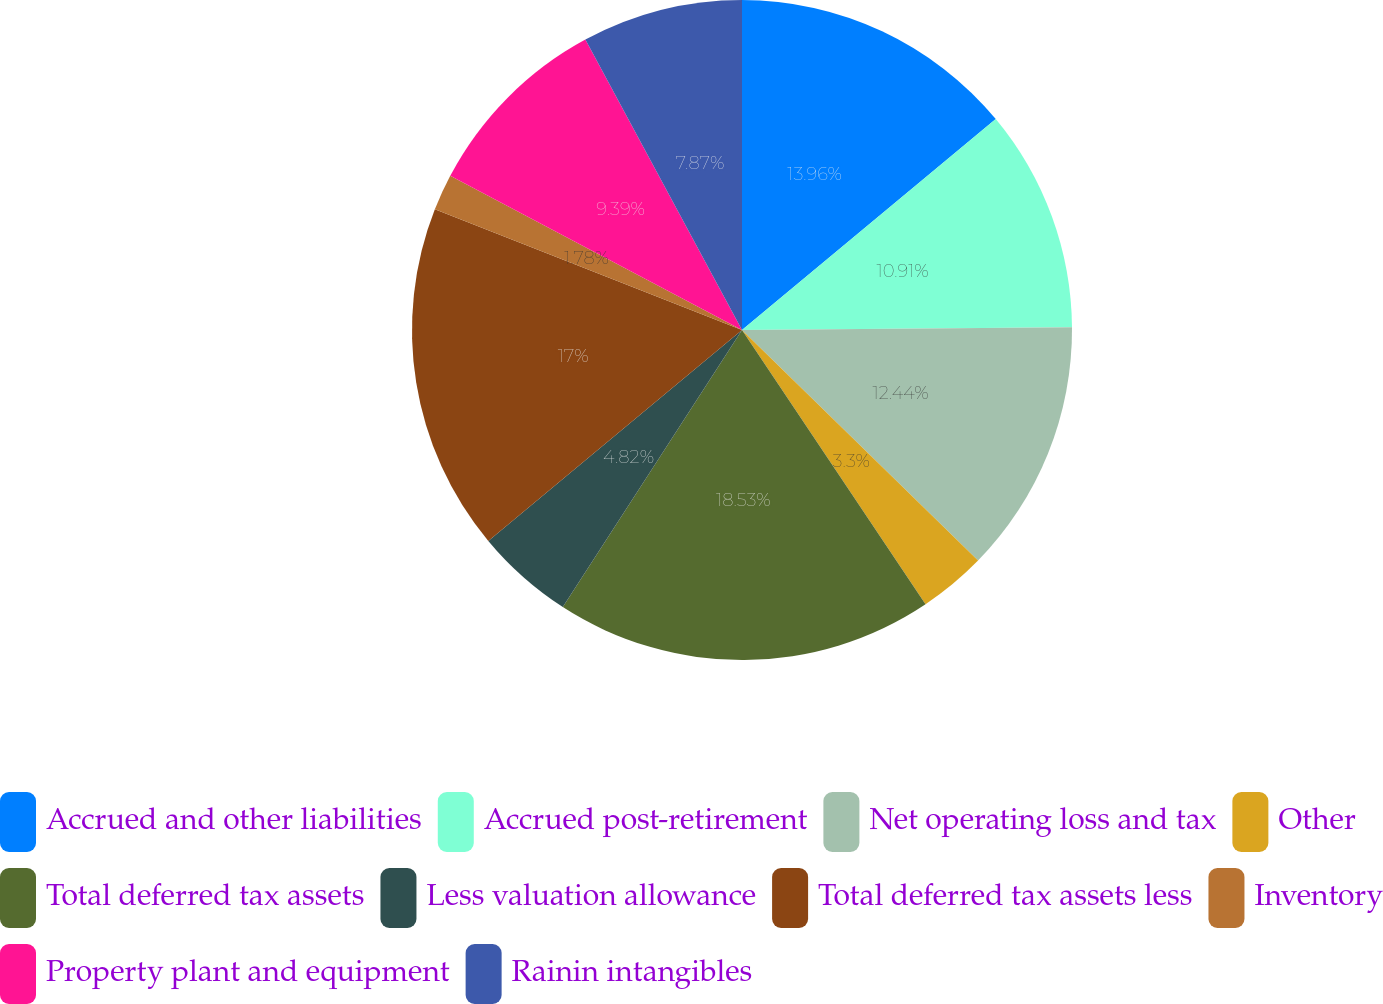Convert chart to OTSL. <chart><loc_0><loc_0><loc_500><loc_500><pie_chart><fcel>Accrued and other liabilities<fcel>Accrued post-retirement<fcel>Net operating loss and tax<fcel>Other<fcel>Total deferred tax assets<fcel>Less valuation allowance<fcel>Total deferred tax assets less<fcel>Inventory<fcel>Property plant and equipment<fcel>Rainin intangibles<nl><fcel>13.96%<fcel>10.91%<fcel>12.44%<fcel>3.3%<fcel>18.52%<fcel>4.82%<fcel>17.0%<fcel>1.78%<fcel>9.39%<fcel>7.87%<nl></chart> 